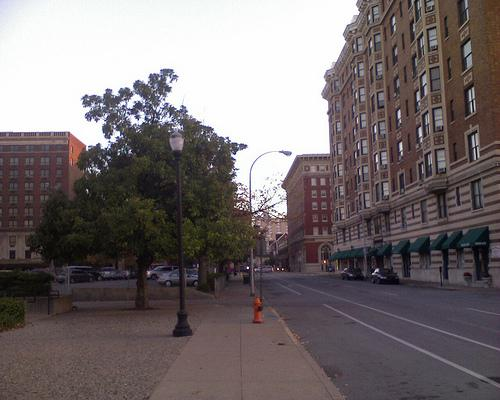Question: why is it bright?
Choices:
A. Sunny.
B. Lights.
C. Outside.
D. Daytime.
Answer with the letter. Answer: A Question: what color is the ground?
Choices:
A. White.
B. Black.
C. Brown.
D. Grey.
Answer with the letter. Answer: D Question: where was the photo taken?
Choices:
A. Lacrosse match.
B. The sidewalk.
C. On the sidewalk.
D. The college.
Answer with the letter. Answer: C Question: who took the photo?
Choices:
A. A camera.
B. An artist.
C. A photographer.
D. A journalist.
Answer with the letter. Answer: C Question: how many street lights?
Choices:
A. Five.
B. Two.
C. Four.
D. Three.
Answer with the letter. Answer: B 